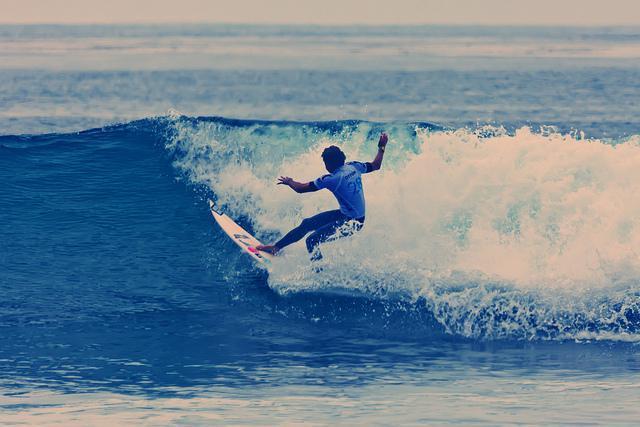How many people are there?
Give a very brief answer. 1. How many cars are visible in the background?
Give a very brief answer. 0. 